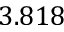Convert formula to latex. <formula><loc_0><loc_0><loc_500><loc_500>3 . 8 1 8</formula> 